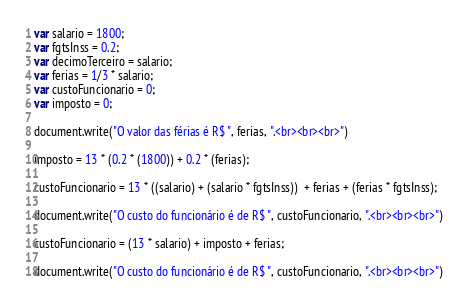<code> <loc_0><loc_0><loc_500><loc_500><_JavaScript_>var salario = 1800;
var fgtsInss = 0.2;
var decimoTerceiro = salario;
var ferias = 1/3 * salario;
var custoFuncionario = 0;
var imposto = 0;

document.write("O valor das férias é R$ ", ferias, ".<br><br><br>")

imposto = 13 * (0.2 * (1800)) + 0.2 * (ferias);

custoFuncionario = 13 * ((salario) + (salario * fgtsInss))  + ferias + (ferias * fgtsInss);

document.write("O custo do funcionário é de R$ ", custoFuncionario, ".<br><br><br>")

custoFuncionario = (13 * salario) + imposto + ferias;

document.write("O custo do funcionário é de R$ ", custoFuncionario, ".<br><br><br>")</code> 